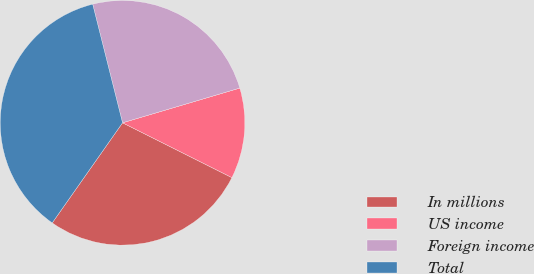Convert chart. <chart><loc_0><loc_0><loc_500><loc_500><pie_chart><fcel>In millions<fcel>US income<fcel>Foreign income<fcel>Total<nl><fcel>27.35%<fcel>11.98%<fcel>24.34%<fcel>36.33%<nl></chart> 